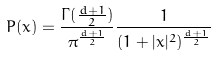<formula> <loc_0><loc_0><loc_500><loc_500>P ( x ) = \frac { \Gamma ( \frac { d + 1 } { 2 } ) } { \pi ^ { \frac { d + 1 } { 2 } } } \frac { 1 } { ( 1 + | x | ^ { 2 } ) ^ { \frac { d + 1 } { 2 } } }</formula> 